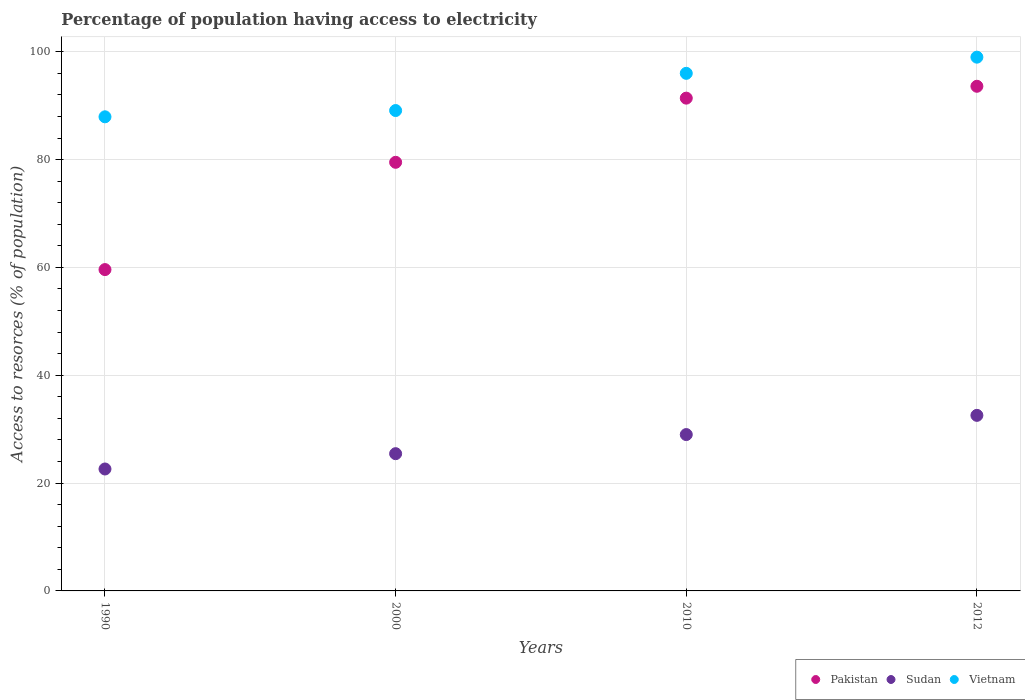How many different coloured dotlines are there?
Keep it short and to the point. 3. Is the number of dotlines equal to the number of legend labels?
Ensure brevity in your answer.  Yes. What is the percentage of population having access to electricity in Sudan in 2010?
Offer a terse response. 29. Across all years, what is the maximum percentage of population having access to electricity in Sudan?
Offer a very short reply. 32.56. Across all years, what is the minimum percentage of population having access to electricity in Pakistan?
Offer a terse response. 59.6. In which year was the percentage of population having access to electricity in Pakistan maximum?
Offer a very short reply. 2012. What is the total percentage of population having access to electricity in Vietnam in the graph?
Offer a terse response. 372.04. What is the difference between the percentage of population having access to electricity in Vietnam in 2000 and that in 2010?
Your answer should be very brief. -6.9. What is the difference between the percentage of population having access to electricity in Sudan in 2010 and the percentage of population having access to electricity in Vietnam in 2012?
Your answer should be compact. -70. What is the average percentage of population having access to electricity in Vietnam per year?
Offer a very short reply. 93.01. In the year 2012, what is the difference between the percentage of population having access to electricity in Vietnam and percentage of population having access to electricity in Sudan?
Give a very brief answer. 66.44. What is the ratio of the percentage of population having access to electricity in Pakistan in 1990 to that in 2000?
Make the answer very short. 0.75. What is the difference between the highest and the second highest percentage of population having access to electricity in Sudan?
Offer a very short reply. 3.56. What is the difference between the highest and the lowest percentage of population having access to electricity in Pakistan?
Offer a terse response. 34. In how many years, is the percentage of population having access to electricity in Vietnam greater than the average percentage of population having access to electricity in Vietnam taken over all years?
Make the answer very short. 2. Is the sum of the percentage of population having access to electricity in Pakistan in 1990 and 2010 greater than the maximum percentage of population having access to electricity in Vietnam across all years?
Keep it short and to the point. Yes. Does the percentage of population having access to electricity in Pakistan monotonically increase over the years?
Offer a very short reply. Yes. Is the percentage of population having access to electricity in Pakistan strictly less than the percentage of population having access to electricity in Vietnam over the years?
Provide a short and direct response. Yes. How many dotlines are there?
Offer a terse response. 3. How many legend labels are there?
Keep it short and to the point. 3. What is the title of the graph?
Your answer should be very brief. Percentage of population having access to electricity. Does "Ecuador" appear as one of the legend labels in the graph?
Your response must be concise. No. What is the label or title of the X-axis?
Your response must be concise. Years. What is the label or title of the Y-axis?
Offer a very short reply. Access to resorces (% of population). What is the Access to resorces (% of population) of Pakistan in 1990?
Provide a short and direct response. 59.6. What is the Access to resorces (% of population) of Sudan in 1990?
Give a very brief answer. 22.62. What is the Access to resorces (% of population) of Vietnam in 1990?
Your response must be concise. 87.94. What is the Access to resorces (% of population) in Pakistan in 2000?
Provide a succinct answer. 79.5. What is the Access to resorces (% of population) in Sudan in 2000?
Ensure brevity in your answer.  25.46. What is the Access to resorces (% of population) of Vietnam in 2000?
Keep it short and to the point. 89.1. What is the Access to resorces (% of population) in Pakistan in 2010?
Give a very brief answer. 91.4. What is the Access to resorces (% of population) of Vietnam in 2010?
Provide a short and direct response. 96. What is the Access to resorces (% of population) of Pakistan in 2012?
Offer a terse response. 93.6. What is the Access to resorces (% of population) of Sudan in 2012?
Make the answer very short. 32.56. What is the Access to resorces (% of population) of Vietnam in 2012?
Your response must be concise. 99. Across all years, what is the maximum Access to resorces (% of population) in Pakistan?
Ensure brevity in your answer.  93.6. Across all years, what is the maximum Access to resorces (% of population) in Sudan?
Give a very brief answer. 32.56. Across all years, what is the minimum Access to resorces (% of population) in Pakistan?
Your response must be concise. 59.6. Across all years, what is the minimum Access to resorces (% of population) in Sudan?
Provide a short and direct response. 22.62. Across all years, what is the minimum Access to resorces (% of population) in Vietnam?
Provide a short and direct response. 87.94. What is the total Access to resorces (% of population) in Pakistan in the graph?
Your answer should be compact. 324.1. What is the total Access to resorces (% of population) in Sudan in the graph?
Offer a very short reply. 109.63. What is the total Access to resorces (% of population) in Vietnam in the graph?
Offer a very short reply. 372.04. What is the difference between the Access to resorces (% of population) of Pakistan in 1990 and that in 2000?
Offer a very short reply. -19.9. What is the difference between the Access to resorces (% of population) in Sudan in 1990 and that in 2000?
Offer a very short reply. -2.84. What is the difference between the Access to resorces (% of population) in Vietnam in 1990 and that in 2000?
Provide a short and direct response. -1.16. What is the difference between the Access to resorces (% of population) of Pakistan in 1990 and that in 2010?
Offer a terse response. -31.8. What is the difference between the Access to resorces (% of population) of Sudan in 1990 and that in 2010?
Make the answer very short. -6.38. What is the difference between the Access to resorces (% of population) of Vietnam in 1990 and that in 2010?
Provide a short and direct response. -8.06. What is the difference between the Access to resorces (% of population) of Pakistan in 1990 and that in 2012?
Make the answer very short. -34. What is the difference between the Access to resorces (% of population) in Sudan in 1990 and that in 2012?
Provide a succinct answer. -9.95. What is the difference between the Access to resorces (% of population) in Vietnam in 1990 and that in 2012?
Make the answer very short. -11.06. What is the difference between the Access to resorces (% of population) in Pakistan in 2000 and that in 2010?
Ensure brevity in your answer.  -11.9. What is the difference between the Access to resorces (% of population) in Sudan in 2000 and that in 2010?
Offer a terse response. -3.54. What is the difference between the Access to resorces (% of population) of Pakistan in 2000 and that in 2012?
Provide a short and direct response. -14.1. What is the difference between the Access to resorces (% of population) in Sudan in 2000 and that in 2012?
Keep it short and to the point. -7.11. What is the difference between the Access to resorces (% of population) of Vietnam in 2000 and that in 2012?
Offer a very short reply. -9.9. What is the difference between the Access to resorces (% of population) in Sudan in 2010 and that in 2012?
Provide a short and direct response. -3.56. What is the difference between the Access to resorces (% of population) of Pakistan in 1990 and the Access to resorces (% of population) of Sudan in 2000?
Provide a succinct answer. 34.14. What is the difference between the Access to resorces (% of population) in Pakistan in 1990 and the Access to resorces (% of population) in Vietnam in 2000?
Give a very brief answer. -29.5. What is the difference between the Access to resorces (% of population) in Sudan in 1990 and the Access to resorces (% of population) in Vietnam in 2000?
Provide a short and direct response. -66.48. What is the difference between the Access to resorces (% of population) in Pakistan in 1990 and the Access to resorces (% of population) in Sudan in 2010?
Your response must be concise. 30.6. What is the difference between the Access to resorces (% of population) in Pakistan in 1990 and the Access to resorces (% of population) in Vietnam in 2010?
Make the answer very short. -36.4. What is the difference between the Access to resorces (% of population) of Sudan in 1990 and the Access to resorces (% of population) of Vietnam in 2010?
Ensure brevity in your answer.  -73.38. What is the difference between the Access to resorces (% of population) in Pakistan in 1990 and the Access to resorces (% of population) in Sudan in 2012?
Provide a succinct answer. 27.04. What is the difference between the Access to resorces (% of population) of Pakistan in 1990 and the Access to resorces (% of population) of Vietnam in 2012?
Make the answer very short. -39.4. What is the difference between the Access to resorces (% of population) in Sudan in 1990 and the Access to resorces (% of population) in Vietnam in 2012?
Ensure brevity in your answer.  -76.38. What is the difference between the Access to resorces (% of population) in Pakistan in 2000 and the Access to resorces (% of population) in Sudan in 2010?
Make the answer very short. 50.5. What is the difference between the Access to resorces (% of population) in Pakistan in 2000 and the Access to resorces (% of population) in Vietnam in 2010?
Your answer should be compact. -16.5. What is the difference between the Access to resorces (% of population) in Sudan in 2000 and the Access to resorces (% of population) in Vietnam in 2010?
Provide a short and direct response. -70.54. What is the difference between the Access to resorces (% of population) in Pakistan in 2000 and the Access to resorces (% of population) in Sudan in 2012?
Provide a succinct answer. 46.94. What is the difference between the Access to resorces (% of population) of Pakistan in 2000 and the Access to resorces (% of population) of Vietnam in 2012?
Make the answer very short. -19.5. What is the difference between the Access to resorces (% of population) of Sudan in 2000 and the Access to resorces (% of population) of Vietnam in 2012?
Keep it short and to the point. -73.54. What is the difference between the Access to resorces (% of population) in Pakistan in 2010 and the Access to resorces (% of population) in Sudan in 2012?
Offer a very short reply. 58.84. What is the difference between the Access to resorces (% of population) in Pakistan in 2010 and the Access to resorces (% of population) in Vietnam in 2012?
Offer a very short reply. -7.6. What is the difference between the Access to resorces (% of population) in Sudan in 2010 and the Access to resorces (% of population) in Vietnam in 2012?
Provide a succinct answer. -70. What is the average Access to resorces (% of population) in Pakistan per year?
Provide a succinct answer. 81.03. What is the average Access to resorces (% of population) in Sudan per year?
Ensure brevity in your answer.  27.41. What is the average Access to resorces (% of population) of Vietnam per year?
Provide a short and direct response. 93.01. In the year 1990, what is the difference between the Access to resorces (% of population) in Pakistan and Access to resorces (% of population) in Sudan?
Provide a short and direct response. 36.98. In the year 1990, what is the difference between the Access to resorces (% of population) of Pakistan and Access to resorces (% of population) of Vietnam?
Make the answer very short. -28.34. In the year 1990, what is the difference between the Access to resorces (% of population) of Sudan and Access to resorces (% of population) of Vietnam?
Your answer should be very brief. -65.32. In the year 2000, what is the difference between the Access to resorces (% of population) in Pakistan and Access to resorces (% of population) in Sudan?
Offer a very short reply. 54.04. In the year 2000, what is the difference between the Access to resorces (% of population) of Sudan and Access to resorces (% of population) of Vietnam?
Offer a very short reply. -63.64. In the year 2010, what is the difference between the Access to resorces (% of population) in Pakistan and Access to resorces (% of population) in Sudan?
Offer a very short reply. 62.4. In the year 2010, what is the difference between the Access to resorces (% of population) of Sudan and Access to resorces (% of population) of Vietnam?
Ensure brevity in your answer.  -67. In the year 2012, what is the difference between the Access to resorces (% of population) in Pakistan and Access to resorces (% of population) in Sudan?
Your answer should be very brief. 61.04. In the year 2012, what is the difference between the Access to resorces (% of population) of Sudan and Access to resorces (% of population) of Vietnam?
Offer a terse response. -66.44. What is the ratio of the Access to resorces (% of population) in Pakistan in 1990 to that in 2000?
Give a very brief answer. 0.75. What is the ratio of the Access to resorces (% of population) of Sudan in 1990 to that in 2000?
Provide a short and direct response. 0.89. What is the ratio of the Access to resorces (% of population) of Vietnam in 1990 to that in 2000?
Your response must be concise. 0.99. What is the ratio of the Access to resorces (% of population) in Pakistan in 1990 to that in 2010?
Your response must be concise. 0.65. What is the ratio of the Access to resorces (% of population) in Sudan in 1990 to that in 2010?
Make the answer very short. 0.78. What is the ratio of the Access to resorces (% of population) of Vietnam in 1990 to that in 2010?
Make the answer very short. 0.92. What is the ratio of the Access to resorces (% of population) of Pakistan in 1990 to that in 2012?
Provide a succinct answer. 0.64. What is the ratio of the Access to resorces (% of population) of Sudan in 1990 to that in 2012?
Provide a succinct answer. 0.69. What is the ratio of the Access to resorces (% of population) in Vietnam in 1990 to that in 2012?
Give a very brief answer. 0.89. What is the ratio of the Access to resorces (% of population) of Pakistan in 2000 to that in 2010?
Offer a very short reply. 0.87. What is the ratio of the Access to resorces (% of population) of Sudan in 2000 to that in 2010?
Provide a short and direct response. 0.88. What is the ratio of the Access to resorces (% of population) of Vietnam in 2000 to that in 2010?
Offer a terse response. 0.93. What is the ratio of the Access to resorces (% of population) in Pakistan in 2000 to that in 2012?
Provide a short and direct response. 0.85. What is the ratio of the Access to resorces (% of population) of Sudan in 2000 to that in 2012?
Your answer should be compact. 0.78. What is the ratio of the Access to resorces (% of population) in Pakistan in 2010 to that in 2012?
Ensure brevity in your answer.  0.98. What is the ratio of the Access to resorces (% of population) of Sudan in 2010 to that in 2012?
Your response must be concise. 0.89. What is the ratio of the Access to resorces (% of population) of Vietnam in 2010 to that in 2012?
Offer a terse response. 0.97. What is the difference between the highest and the second highest Access to resorces (% of population) in Pakistan?
Make the answer very short. 2.2. What is the difference between the highest and the second highest Access to resorces (% of population) of Sudan?
Provide a succinct answer. 3.56. What is the difference between the highest and the lowest Access to resorces (% of population) in Pakistan?
Keep it short and to the point. 34. What is the difference between the highest and the lowest Access to resorces (% of population) of Sudan?
Your answer should be compact. 9.95. What is the difference between the highest and the lowest Access to resorces (% of population) of Vietnam?
Offer a terse response. 11.06. 